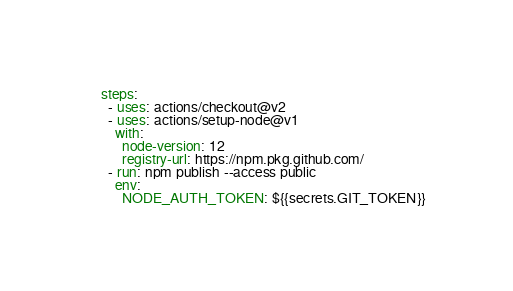Convert code to text. <code><loc_0><loc_0><loc_500><loc_500><_YAML_>    steps:
      - uses: actions/checkout@v2
      - uses: actions/setup-node@v1
        with:
          node-version: 12
          registry-url: https://npm.pkg.github.com/
      - run: npm publish --access public
        env:
          NODE_AUTH_TOKEN: ${{secrets.GIT_TOKEN}}
</code> 